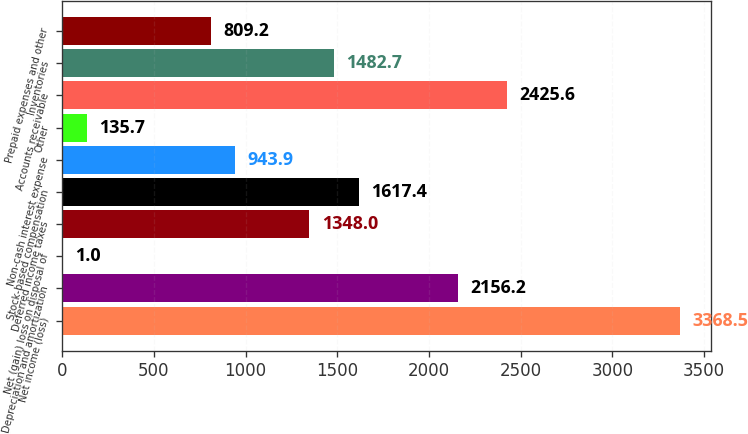<chart> <loc_0><loc_0><loc_500><loc_500><bar_chart><fcel>Net income (loss)<fcel>Depreciation and amortization<fcel>Net (gain) loss on disposal of<fcel>Deferred income taxes<fcel>Stock-based compensation<fcel>Non-cash interest expense<fcel>Other<fcel>Accounts receivable<fcel>Inventories<fcel>Prepaid expenses and other<nl><fcel>3368.5<fcel>2156.2<fcel>1<fcel>1348<fcel>1617.4<fcel>943.9<fcel>135.7<fcel>2425.6<fcel>1482.7<fcel>809.2<nl></chart> 